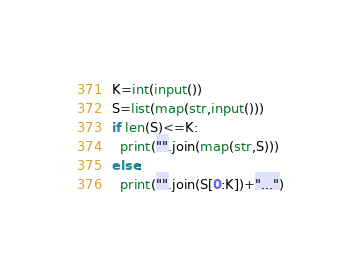Convert code to text. <code><loc_0><loc_0><loc_500><loc_500><_Python_>K=int(input())
S=list(map(str,input()))
if len(S)<=K:
  print("".join(map(str,S)))
else:
  print("".join(S[0:K])+"...")</code> 